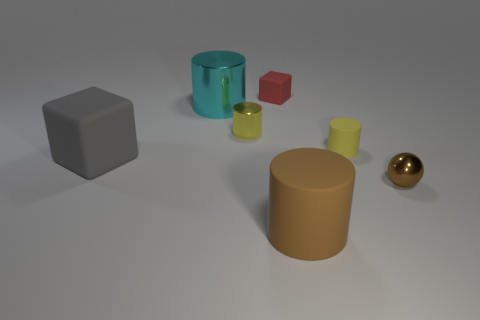What size is the matte cylinder that is right of the large brown matte cylinder?
Ensure brevity in your answer.  Small. There is a rubber thing left of the cyan thing behind the large gray thing; what number of large gray things are behind it?
Ensure brevity in your answer.  0. Do the small ball and the large matte cylinder have the same color?
Your answer should be very brief. Yes. How many cylinders are both behind the big brown matte cylinder and to the left of the small yellow matte cylinder?
Your answer should be very brief. 2. What is the shape of the object that is behind the large cyan cylinder?
Give a very brief answer. Cube. Are there fewer yellow objects that are to the left of the brown matte object than tiny shiny balls right of the small brown metal thing?
Keep it short and to the point. No. Is the big cylinder behind the brown ball made of the same material as the cube that is behind the gray cube?
Provide a short and direct response. No. There is a yellow rubber thing; what shape is it?
Keep it short and to the point. Cylinder. Is the number of tiny brown metal spheres that are left of the ball greater than the number of matte cubes that are left of the big rubber block?
Your response must be concise. No. There is a small metal object behind the tiny brown thing; does it have the same shape as the big thing that is on the right side of the red rubber block?
Provide a short and direct response. Yes. 